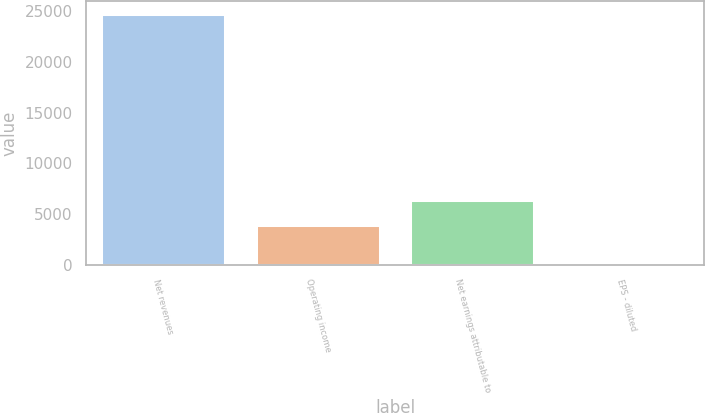Convert chart to OTSL. <chart><loc_0><loc_0><loc_500><loc_500><bar_chart><fcel>Net revenues<fcel>Operating income<fcel>Net earnings attributable to<fcel>EPS - diluted<nl><fcel>24719.5<fcel>3883.3<fcel>6354.93<fcel>3.24<nl></chart> 